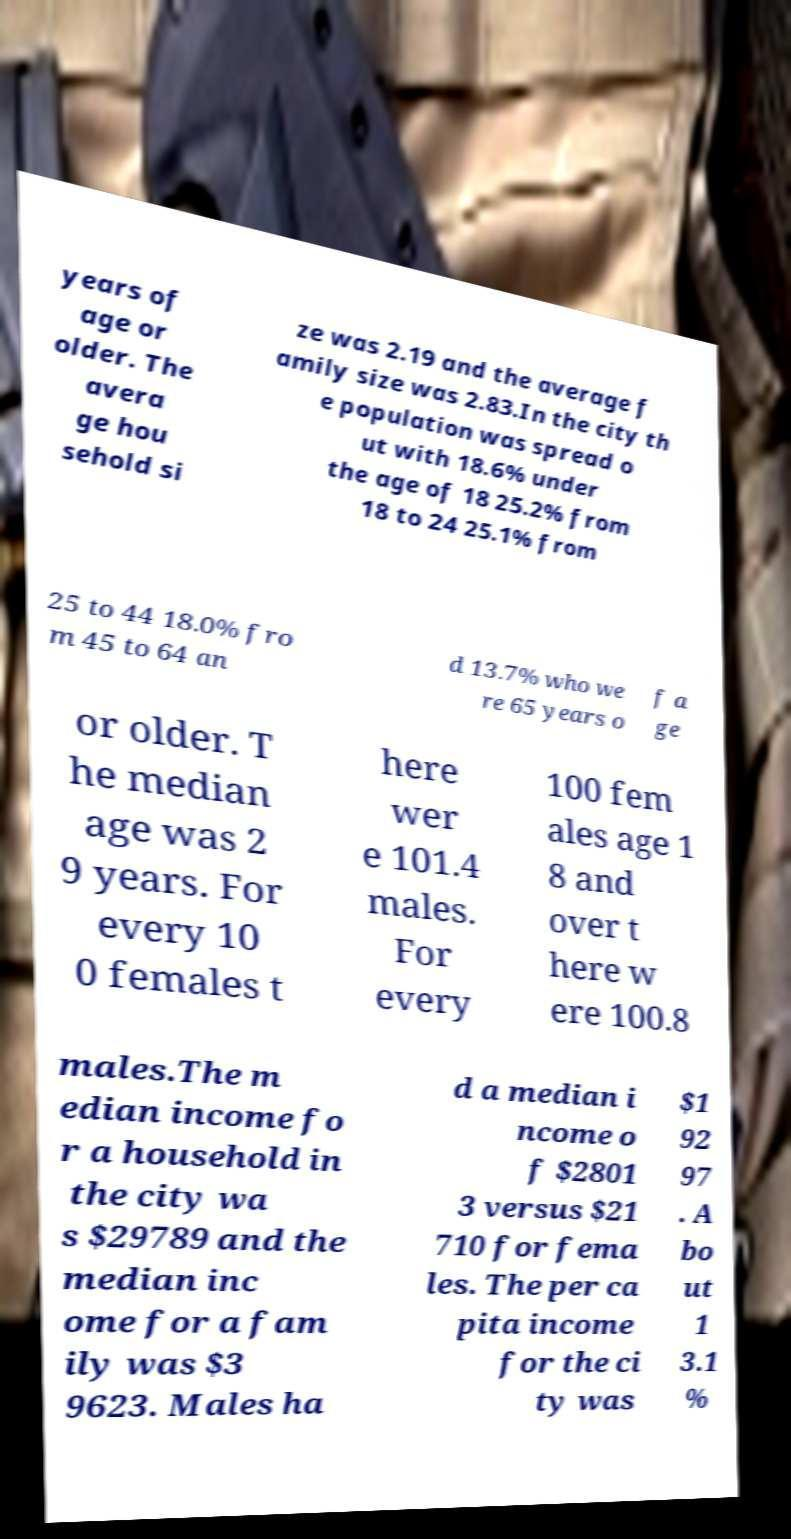Can you accurately transcribe the text from the provided image for me? years of age or older. The avera ge hou sehold si ze was 2.19 and the average f amily size was 2.83.In the city th e population was spread o ut with 18.6% under the age of 18 25.2% from 18 to 24 25.1% from 25 to 44 18.0% fro m 45 to 64 an d 13.7% who we re 65 years o f a ge or older. T he median age was 2 9 years. For every 10 0 females t here wer e 101.4 males. For every 100 fem ales age 1 8 and over t here w ere 100.8 males.The m edian income fo r a household in the city wa s $29789 and the median inc ome for a fam ily was $3 9623. Males ha d a median i ncome o f $2801 3 versus $21 710 for fema les. The per ca pita income for the ci ty was $1 92 97 . A bo ut 1 3.1 % 